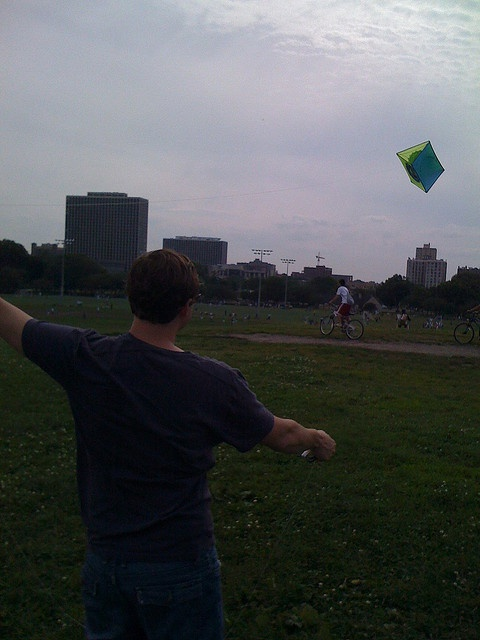Describe the objects in this image and their specific colors. I can see people in darkgray, black, maroon, and gray tones, kite in darkgray, blue, black, olive, and darkgreen tones, bicycle in darkgray, black, and gray tones, bicycle in black, gray, darkgreen, and darkgray tones, and people in darkgray, black, and gray tones in this image. 